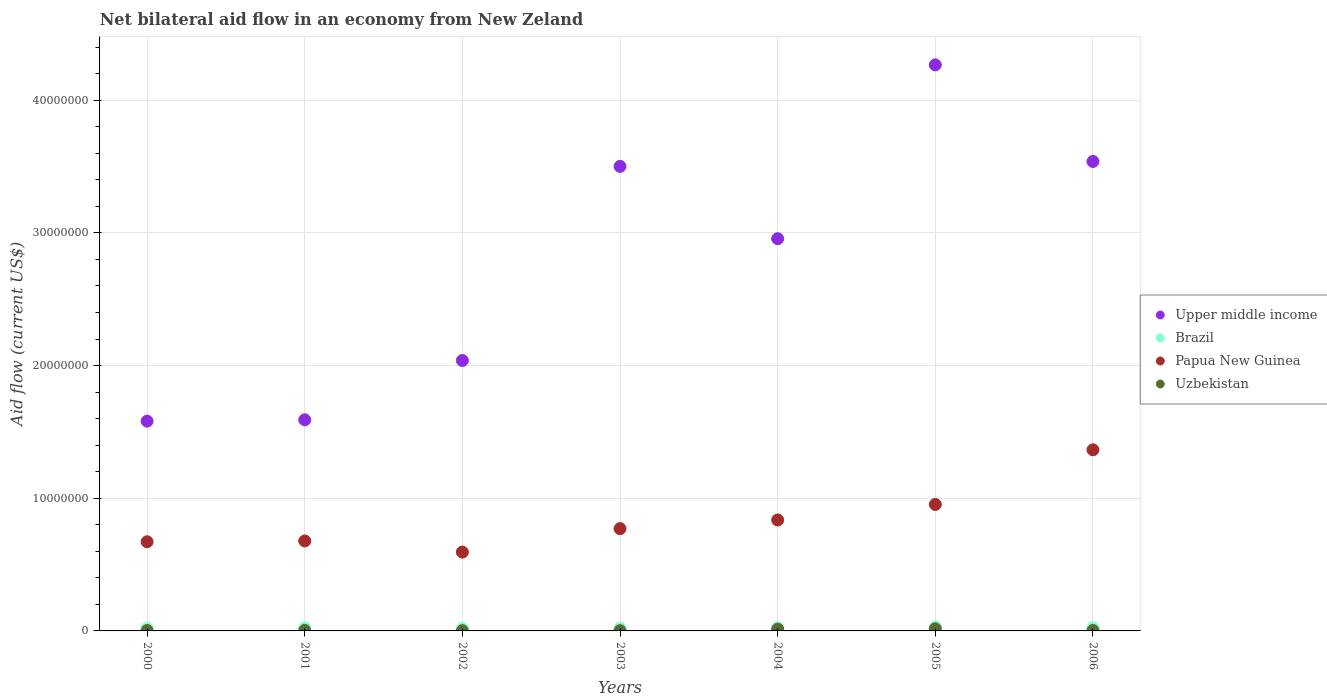What is the net bilateral aid flow in Papua New Guinea in 2001?
Give a very brief answer. 6.78e+06. Across all years, what is the minimum net bilateral aid flow in Uzbekistan?
Provide a short and direct response. 2.00e+04. In which year was the net bilateral aid flow in Papua New Guinea maximum?
Offer a very short reply. 2006. In which year was the net bilateral aid flow in Upper middle income minimum?
Offer a very short reply. 2000. What is the difference between the net bilateral aid flow in Uzbekistan in 2000 and that in 2006?
Your answer should be compact. 0. What is the average net bilateral aid flow in Upper middle income per year?
Provide a succinct answer. 2.78e+07. In the year 2006, what is the difference between the net bilateral aid flow in Papua New Guinea and net bilateral aid flow in Brazil?
Your answer should be compact. 1.34e+07. What is the ratio of the net bilateral aid flow in Brazil in 2003 to that in 2005?
Your answer should be compact. 0.69. Is the net bilateral aid flow in Brazil in 2005 less than that in 2006?
Make the answer very short. No. What is the difference between the highest and the lowest net bilateral aid flow in Papua New Guinea?
Offer a very short reply. 7.71e+06. Is the net bilateral aid flow in Upper middle income strictly greater than the net bilateral aid flow in Uzbekistan over the years?
Offer a very short reply. Yes. How many years are there in the graph?
Offer a very short reply. 7. Where does the legend appear in the graph?
Keep it short and to the point. Center right. How many legend labels are there?
Ensure brevity in your answer.  4. How are the legend labels stacked?
Provide a short and direct response. Vertical. What is the title of the graph?
Offer a terse response. Net bilateral aid flow in an economy from New Zeland. What is the label or title of the Y-axis?
Provide a short and direct response. Aid flow (current US$). What is the Aid flow (current US$) of Upper middle income in 2000?
Provide a succinct answer. 1.58e+07. What is the Aid flow (current US$) of Brazil in 2000?
Give a very brief answer. 2.10e+05. What is the Aid flow (current US$) in Papua New Guinea in 2000?
Keep it short and to the point. 6.72e+06. What is the Aid flow (current US$) in Uzbekistan in 2000?
Ensure brevity in your answer.  3.00e+04. What is the Aid flow (current US$) of Upper middle income in 2001?
Give a very brief answer. 1.59e+07. What is the Aid flow (current US$) in Papua New Guinea in 2001?
Give a very brief answer. 6.78e+06. What is the Aid flow (current US$) of Uzbekistan in 2001?
Provide a short and direct response. 4.00e+04. What is the Aid flow (current US$) of Upper middle income in 2002?
Offer a very short reply. 2.04e+07. What is the Aid flow (current US$) of Papua New Guinea in 2002?
Give a very brief answer. 5.94e+06. What is the Aid flow (current US$) in Uzbekistan in 2002?
Your answer should be compact. 2.00e+04. What is the Aid flow (current US$) in Upper middle income in 2003?
Offer a very short reply. 3.50e+07. What is the Aid flow (current US$) of Papua New Guinea in 2003?
Keep it short and to the point. 7.71e+06. What is the Aid flow (current US$) of Uzbekistan in 2003?
Offer a terse response. 2.00e+04. What is the Aid flow (current US$) in Upper middle income in 2004?
Your answer should be compact. 2.96e+07. What is the Aid flow (current US$) in Brazil in 2004?
Make the answer very short. 2.40e+05. What is the Aid flow (current US$) in Papua New Guinea in 2004?
Provide a succinct answer. 8.36e+06. What is the Aid flow (current US$) in Upper middle income in 2005?
Offer a very short reply. 4.27e+07. What is the Aid flow (current US$) in Brazil in 2005?
Offer a very short reply. 2.90e+05. What is the Aid flow (current US$) in Papua New Guinea in 2005?
Your answer should be very brief. 9.53e+06. What is the Aid flow (current US$) in Upper middle income in 2006?
Offer a terse response. 3.54e+07. What is the Aid flow (current US$) of Papua New Guinea in 2006?
Your response must be concise. 1.36e+07. Across all years, what is the maximum Aid flow (current US$) of Upper middle income?
Your answer should be very brief. 4.27e+07. Across all years, what is the maximum Aid flow (current US$) of Papua New Guinea?
Keep it short and to the point. 1.36e+07. Across all years, what is the minimum Aid flow (current US$) in Upper middle income?
Provide a succinct answer. 1.58e+07. Across all years, what is the minimum Aid flow (current US$) in Brazil?
Offer a terse response. 1.80e+05. Across all years, what is the minimum Aid flow (current US$) in Papua New Guinea?
Offer a terse response. 5.94e+06. Across all years, what is the minimum Aid flow (current US$) of Uzbekistan?
Offer a terse response. 2.00e+04. What is the total Aid flow (current US$) of Upper middle income in the graph?
Your response must be concise. 1.95e+08. What is the total Aid flow (current US$) of Brazil in the graph?
Your answer should be compact. 1.60e+06. What is the total Aid flow (current US$) of Papua New Guinea in the graph?
Ensure brevity in your answer.  5.87e+07. What is the total Aid flow (current US$) of Uzbekistan in the graph?
Offer a terse response. 4.30e+05. What is the difference between the Aid flow (current US$) in Brazil in 2000 and that in 2001?
Offer a very short reply. -3.00e+04. What is the difference between the Aid flow (current US$) of Papua New Guinea in 2000 and that in 2001?
Your response must be concise. -6.00e+04. What is the difference between the Aid flow (current US$) in Upper middle income in 2000 and that in 2002?
Keep it short and to the point. -4.57e+06. What is the difference between the Aid flow (current US$) of Papua New Guinea in 2000 and that in 2002?
Provide a short and direct response. 7.80e+05. What is the difference between the Aid flow (current US$) of Upper middle income in 2000 and that in 2003?
Offer a terse response. -1.92e+07. What is the difference between the Aid flow (current US$) in Brazil in 2000 and that in 2003?
Make the answer very short. 10000. What is the difference between the Aid flow (current US$) in Papua New Guinea in 2000 and that in 2003?
Ensure brevity in your answer.  -9.90e+05. What is the difference between the Aid flow (current US$) of Uzbekistan in 2000 and that in 2003?
Your response must be concise. 10000. What is the difference between the Aid flow (current US$) in Upper middle income in 2000 and that in 2004?
Provide a succinct answer. -1.38e+07. What is the difference between the Aid flow (current US$) of Papua New Guinea in 2000 and that in 2004?
Your response must be concise. -1.64e+06. What is the difference between the Aid flow (current US$) of Uzbekistan in 2000 and that in 2004?
Offer a terse response. -1.00e+05. What is the difference between the Aid flow (current US$) of Upper middle income in 2000 and that in 2005?
Offer a terse response. -2.68e+07. What is the difference between the Aid flow (current US$) in Brazil in 2000 and that in 2005?
Offer a terse response. -8.00e+04. What is the difference between the Aid flow (current US$) of Papua New Guinea in 2000 and that in 2005?
Your answer should be compact. -2.81e+06. What is the difference between the Aid flow (current US$) of Upper middle income in 2000 and that in 2006?
Provide a succinct answer. -1.96e+07. What is the difference between the Aid flow (current US$) of Brazil in 2000 and that in 2006?
Provide a succinct answer. -3.00e+04. What is the difference between the Aid flow (current US$) in Papua New Guinea in 2000 and that in 2006?
Ensure brevity in your answer.  -6.93e+06. What is the difference between the Aid flow (current US$) of Uzbekistan in 2000 and that in 2006?
Provide a short and direct response. 0. What is the difference between the Aid flow (current US$) in Upper middle income in 2001 and that in 2002?
Offer a terse response. -4.47e+06. What is the difference between the Aid flow (current US$) in Papua New Guinea in 2001 and that in 2002?
Your response must be concise. 8.40e+05. What is the difference between the Aid flow (current US$) in Upper middle income in 2001 and that in 2003?
Offer a very short reply. -1.91e+07. What is the difference between the Aid flow (current US$) of Papua New Guinea in 2001 and that in 2003?
Offer a terse response. -9.30e+05. What is the difference between the Aid flow (current US$) in Uzbekistan in 2001 and that in 2003?
Provide a short and direct response. 2.00e+04. What is the difference between the Aid flow (current US$) in Upper middle income in 2001 and that in 2004?
Make the answer very short. -1.36e+07. What is the difference between the Aid flow (current US$) of Brazil in 2001 and that in 2004?
Offer a terse response. 0. What is the difference between the Aid flow (current US$) in Papua New Guinea in 2001 and that in 2004?
Offer a terse response. -1.58e+06. What is the difference between the Aid flow (current US$) of Upper middle income in 2001 and that in 2005?
Your answer should be very brief. -2.68e+07. What is the difference between the Aid flow (current US$) of Papua New Guinea in 2001 and that in 2005?
Give a very brief answer. -2.75e+06. What is the difference between the Aid flow (current US$) in Uzbekistan in 2001 and that in 2005?
Provide a succinct answer. -1.20e+05. What is the difference between the Aid flow (current US$) in Upper middle income in 2001 and that in 2006?
Keep it short and to the point. -1.95e+07. What is the difference between the Aid flow (current US$) of Papua New Guinea in 2001 and that in 2006?
Keep it short and to the point. -6.87e+06. What is the difference between the Aid flow (current US$) in Uzbekistan in 2001 and that in 2006?
Your response must be concise. 10000. What is the difference between the Aid flow (current US$) of Upper middle income in 2002 and that in 2003?
Give a very brief answer. -1.46e+07. What is the difference between the Aid flow (current US$) of Papua New Guinea in 2002 and that in 2003?
Provide a succinct answer. -1.77e+06. What is the difference between the Aid flow (current US$) of Uzbekistan in 2002 and that in 2003?
Your answer should be very brief. 0. What is the difference between the Aid flow (current US$) of Upper middle income in 2002 and that in 2004?
Your answer should be compact. -9.18e+06. What is the difference between the Aid flow (current US$) of Brazil in 2002 and that in 2004?
Make the answer very short. -6.00e+04. What is the difference between the Aid flow (current US$) in Papua New Guinea in 2002 and that in 2004?
Your answer should be compact. -2.42e+06. What is the difference between the Aid flow (current US$) in Uzbekistan in 2002 and that in 2004?
Your response must be concise. -1.10e+05. What is the difference between the Aid flow (current US$) in Upper middle income in 2002 and that in 2005?
Your response must be concise. -2.23e+07. What is the difference between the Aid flow (current US$) of Brazil in 2002 and that in 2005?
Your answer should be compact. -1.10e+05. What is the difference between the Aid flow (current US$) of Papua New Guinea in 2002 and that in 2005?
Provide a succinct answer. -3.59e+06. What is the difference between the Aid flow (current US$) of Uzbekistan in 2002 and that in 2005?
Your answer should be compact. -1.40e+05. What is the difference between the Aid flow (current US$) of Upper middle income in 2002 and that in 2006?
Your answer should be compact. -1.50e+07. What is the difference between the Aid flow (current US$) of Papua New Guinea in 2002 and that in 2006?
Keep it short and to the point. -7.71e+06. What is the difference between the Aid flow (current US$) of Uzbekistan in 2002 and that in 2006?
Your answer should be compact. -10000. What is the difference between the Aid flow (current US$) of Upper middle income in 2003 and that in 2004?
Ensure brevity in your answer.  5.45e+06. What is the difference between the Aid flow (current US$) of Papua New Guinea in 2003 and that in 2004?
Your answer should be compact. -6.50e+05. What is the difference between the Aid flow (current US$) in Uzbekistan in 2003 and that in 2004?
Provide a short and direct response. -1.10e+05. What is the difference between the Aid flow (current US$) in Upper middle income in 2003 and that in 2005?
Make the answer very short. -7.65e+06. What is the difference between the Aid flow (current US$) of Brazil in 2003 and that in 2005?
Your answer should be compact. -9.00e+04. What is the difference between the Aid flow (current US$) in Papua New Guinea in 2003 and that in 2005?
Provide a succinct answer. -1.82e+06. What is the difference between the Aid flow (current US$) in Upper middle income in 2003 and that in 2006?
Provide a short and direct response. -3.70e+05. What is the difference between the Aid flow (current US$) of Papua New Guinea in 2003 and that in 2006?
Offer a very short reply. -5.94e+06. What is the difference between the Aid flow (current US$) of Upper middle income in 2004 and that in 2005?
Ensure brevity in your answer.  -1.31e+07. What is the difference between the Aid flow (current US$) of Brazil in 2004 and that in 2005?
Provide a short and direct response. -5.00e+04. What is the difference between the Aid flow (current US$) of Papua New Guinea in 2004 and that in 2005?
Offer a very short reply. -1.17e+06. What is the difference between the Aid flow (current US$) of Uzbekistan in 2004 and that in 2005?
Offer a very short reply. -3.00e+04. What is the difference between the Aid flow (current US$) in Upper middle income in 2004 and that in 2006?
Provide a short and direct response. -5.82e+06. What is the difference between the Aid flow (current US$) of Papua New Guinea in 2004 and that in 2006?
Your answer should be compact. -5.29e+06. What is the difference between the Aid flow (current US$) of Upper middle income in 2005 and that in 2006?
Your answer should be compact. 7.28e+06. What is the difference between the Aid flow (current US$) in Papua New Guinea in 2005 and that in 2006?
Your answer should be very brief. -4.12e+06. What is the difference between the Aid flow (current US$) in Uzbekistan in 2005 and that in 2006?
Make the answer very short. 1.30e+05. What is the difference between the Aid flow (current US$) of Upper middle income in 2000 and the Aid flow (current US$) of Brazil in 2001?
Your response must be concise. 1.56e+07. What is the difference between the Aid flow (current US$) of Upper middle income in 2000 and the Aid flow (current US$) of Papua New Guinea in 2001?
Make the answer very short. 9.03e+06. What is the difference between the Aid flow (current US$) in Upper middle income in 2000 and the Aid flow (current US$) in Uzbekistan in 2001?
Keep it short and to the point. 1.58e+07. What is the difference between the Aid flow (current US$) of Brazil in 2000 and the Aid flow (current US$) of Papua New Guinea in 2001?
Ensure brevity in your answer.  -6.57e+06. What is the difference between the Aid flow (current US$) in Brazil in 2000 and the Aid flow (current US$) in Uzbekistan in 2001?
Your response must be concise. 1.70e+05. What is the difference between the Aid flow (current US$) in Papua New Guinea in 2000 and the Aid flow (current US$) in Uzbekistan in 2001?
Your answer should be compact. 6.68e+06. What is the difference between the Aid flow (current US$) of Upper middle income in 2000 and the Aid flow (current US$) of Brazil in 2002?
Keep it short and to the point. 1.56e+07. What is the difference between the Aid flow (current US$) in Upper middle income in 2000 and the Aid flow (current US$) in Papua New Guinea in 2002?
Provide a succinct answer. 9.87e+06. What is the difference between the Aid flow (current US$) of Upper middle income in 2000 and the Aid flow (current US$) of Uzbekistan in 2002?
Make the answer very short. 1.58e+07. What is the difference between the Aid flow (current US$) of Brazil in 2000 and the Aid flow (current US$) of Papua New Guinea in 2002?
Ensure brevity in your answer.  -5.73e+06. What is the difference between the Aid flow (current US$) of Brazil in 2000 and the Aid flow (current US$) of Uzbekistan in 2002?
Your answer should be very brief. 1.90e+05. What is the difference between the Aid flow (current US$) in Papua New Guinea in 2000 and the Aid flow (current US$) in Uzbekistan in 2002?
Keep it short and to the point. 6.70e+06. What is the difference between the Aid flow (current US$) in Upper middle income in 2000 and the Aid flow (current US$) in Brazil in 2003?
Keep it short and to the point. 1.56e+07. What is the difference between the Aid flow (current US$) in Upper middle income in 2000 and the Aid flow (current US$) in Papua New Guinea in 2003?
Keep it short and to the point. 8.10e+06. What is the difference between the Aid flow (current US$) of Upper middle income in 2000 and the Aid flow (current US$) of Uzbekistan in 2003?
Keep it short and to the point. 1.58e+07. What is the difference between the Aid flow (current US$) in Brazil in 2000 and the Aid flow (current US$) in Papua New Guinea in 2003?
Make the answer very short. -7.50e+06. What is the difference between the Aid flow (current US$) in Papua New Guinea in 2000 and the Aid flow (current US$) in Uzbekistan in 2003?
Offer a terse response. 6.70e+06. What is the difference between the Aid flow (current US$) in Upper middle income in 2000 and the Aid flow (current US$) in Brazil in 2004?
Provide a succinct answer. 1.56e+07. What is the difference between the Aid flow (current US$) of Upper middle income in 2000 and the Aid flow (current US$) of Papua New Guinea in 2004?
Your answer should be compact. 7.45e+06. What is the difference between the Aid flow (current US$) in Upper middle income in 2000 and the Aid flow (current US$) in Uzbekistan in 2004?
Offer a very short reply. 1.57e+07. What is the difference between the Aid flow (current US$) in Brazil in 2000 and the Aid flow (current US$) in Papua New Guinea in 2004?
Give a very brief answer. -8.15e+06. What is the difference between the Aid flow (current US$) in Papua New Guinea in 2000 and the Aid flow (current US$) in Uzbekistan in 2004?
Offer a very short reply. 6.59e+06. What is the difference between the Aid flow (current US$) of Upper middle income in 2000 and the Aid flow (current US$) of Brazil in 2005?
Offer a terse response. 1.55e+07. What is the difference between the Aid flow (current US$) in Upper middle income in 2000 and the Aid flow (current US$) in Papua New Guinea in 2005?
Offer a terse response. 6.28e+06. What is the difference between the Aid flow (current US$) of Upper middle income in 2000 and the Aid flow (current US$) of Uzbekistan in 2005?
Give a very brief answer. 1.56e+07. What is the difference between the Aid flow (current US$) of Brazil in 2000 and the Aid flow (current US$) of Papua New Guinea in 2005?
Offer a very short reply. -9.32e+06. What is the difference between the Aid flow (current US$) in Papua New Guinea in 2000 and the Aid flow (current US$) in Uzbekistan in 2005?
Make the answer very short. 6.56e+06. What is the difference between the Aid flow (current US$) of Upper middle income in 2000 and the Aid flow (current US$) of Brazil in 2006?
Your answer should be compact. 1.56e+07. What is the difference between the Aid flow (current US$) in Upper middle income in 2000 and the Aid flow (current US$) in Papua New Guinea in 2006?
Ensure brevity in your answer.  2.16e+06. What is the difference between the Aid flow (current US$) in Upper middle income in 2000 and the Aid flow (current US$) in Uzbekistan in 2006?
Offer a terse response. 1.58e+07. What is the difference between the Aid flow (current US$) in Brazil in 2000 and the Aid flow (current US$) in Papua New Guinea in 2006?
Ensure brevity in your answer.  -1.34e+07. What is the difference between the Aid flow (current US$) in Papua New Guinea in 2000 and the Aid flow (current US$) in Uzbekistan in 2006?
Make the answer very short. 6.69e+06. What is the difference between the Aid flow (current US$) of Upper middle income in 2001 and the Aid flow (current US$) of Brazil in 2002?
Give a very brief answer. 1.57e+07. What is the difference between the Aid flow (current US$) in Upper middle income in 2001 and the Aid flow (current US$) in Papua New Guinea in 2002?
Keep it short and to the point. 9.97e+06. What is the difference between the Aid flow (current US$) in Upper middle income in 2001 and the Aid flow (current US$) in Uzbekistan in 2002?
Provide a short and direct response. 1.59e+07. What is the difference between the Aid flow (current US$) in Brazil in 2001 and the Aid flow (current US$) in Papua New Guinea in 2002?
Ensure brevity in your answer.  -5.70e+06. What is the difference between the Aid flow (current US$) of Papua New Guinea in 2001 and the Aid flow (current US$) of Uzbekistan in 2002?
Ensure brevity in your answer.  6.76e+06. What is the difference between the Aid flow (current US$) of Upper middle income in 2001 and the Aid flow (current US$) of Brazil in 2003?
Make the answer very short. 1.57e+07. What is the difference between the Aid flow (current US$) in Upper middle income in 2001 and the Aid flow (current US$) in Papua New Guinea in 2003?
Your answer should be very brief. 8.20e+06. What is the difference between the Aid flow (current US$) in Upper middle income in 2001 and the Aid flow (current US$) in Uzbekistan in 2003?
Your response must be concise. 1.59e+07. What is the difference between the Aid flow (current US$) of Brazil in 2001 and the Aid flow (current US$) of Papua New Guinea in 2003?
Your response must be concise. -7.47e+06. What is the difference between the Aid flow (current US$) in Brazil in 2001 and the Aid flow (current US$) in Uzbekistan in 2003?
Offer a terse response. 2.20e+05. What is the difference between the Aid flow (current US$) in Papua New Guinea in 2001 and the Aid flow (current US$) in Uzbekistan in 2003?
Your answer should be very brief. 6.76e+06. What is the difference between the Aid flow (current US$) in Upper middle income in 2001 and the Aid flow (current US$) in Brazil in 2004?
Your answer should be very brief. 1.57e+07. What is the difference between the Aid flow (current US$) of Upper middle income in 2001 and the Aid flow (current US$) of Papua New Guinea in 2004?
Your answer should be compact. 7.55e+06. What is the difference between the Aid flow (current US$) of Upper middle income in 2001 and the Aid flow (current US$) of Uzbekistan in 2004?
Keep it short and to the point. 1.58e+07. What is the difference between the Aid flow (current US$) of Brazil in 2001 and the Aid flow (current US$) of Papua New Guinea in 2004?
Your answer should be compact. -8.12e+06. What is the difference between the Aid flow (current US$) of Papua New Guinea in 2001 and the Aid flow (current US$) of Uzbekistan in 2004?
Give a very brief answer. 6.65e+06. What is the difference between the Aid flow (current US$) of Upper middle income in 2001 and the Aid flow (current US$) of Brazil in 2005?
Your response must be concise. 1.56e+07. What is the difference between the Aid flow (current US$) in Upper middle income in 2001 and the Aid flow (current US$) in Papua New Guinea in 2005?
Offer a terse response. 6.38e+06. What is the difference between the Aid flow (current US$) in Upper middle income in 2001 and the Aid flow (current US$) in Uzbekistan in 2005?
Give a very brief answer. 1.58e+07. What is the difference between the Aid flow (current US$) of Brazil in 2001 and the Aid flow (current US$) of Papua New Guinea in 2005?
Your answer should be very brief. -9.29e+06. What is the difference between the Aid flow (current US$) of Papua New Guinea in 2001 and the Aid flow (current US$) of Uzbekistan in 2005?
Provide a short and direct response. 6.62e+06. What is the difference between the Aid flow (current US$) in Upper middle income in 2001 and the Aid flow (current US$) in Brazil in 2006?
Offer a terse response. 1.57e+07. What is the difference between the Aid flow (current US$) of Upper middle income in 2001 and the Aid flow (current US$) of Papua New Guinea in 2006?
Keep it short and to the point. 2.26e+06. What is the difference between the Aid flow (current US$) of Upper middle income in 2001 and the Aid flow (current US$) of Uzbekistan in 2006?
Give a very brief answer. 1.59e+07. What is the difference between the Aid flow (current US$) of Brazil in 2001 and the Aid flow (current US$) of Papua New Guinea in 2006?
Keep it short and to the point. -1.34e+07. What is the difference between the Aid flow (current US$) in Brazil in 2001 and the Aid flow (current US$) in Uzbekistan in 2006?
Provide a short and direct response. 2.10e+05. What is the difference between the Aid flow (current US$) of Papua New Guinea in 2001 and the Aid flow (current US$) of Uzbekistan in 2006?
Your answer should be compact. 6.75e+06. What is the difference between the Aid flow (current US$) of Upper middle income in 2002 and the Aid flow (current US$) of Brazil in 2003?
Keep it short and to the point. 2.02e+07. What is the difference between the Aid flow (current US$) of Upper middle income in 2002 and the Aid flow (current US$) of Papua New Guinea in 2003?
Ensure brevity in your answer.  1.27e+07. What is the difference between the Aid flow (current US$) in Upper middle income in 2002 and the Aid flow (current US$) in Uzbekistan in 2003?
Ensure brevity in your answer.  2.04e+07. What is the difference between the Aid flow (current US$) in Brazil in 2002 and the Aid flow (current US$) in Papua New Guinea in 2003?
Your response must be concise. -7.53e+06. What is the difference between the Aid flow (current US$) of Brazil in 2002 and the Aid flow (current US$) of Uzbekistan in 2003?
Offer a terse response. 1.60e+05. What is the difference between the Aid flow (current US$) of Papua New Guinea in 2002 and the Aid flow (current US$) of Uzbekistan in 2003?
Give a very brief answer. 5.92e+06. What is the difference between the Aid flow (current US$) in Upper middle income in 2002 and the Aid flow (current US$) in Brazil in 2004?
Keep it short and to the point. 2.01e+07. What is the difference between the Aid flow (current US$) of Upper middle income in 2002 and the Aid flow (current US$) of Papua New Guinea in 2004?
Offer a very short reply. 1.20e+07. What is the difference between the Aid flow (current US$) in Upper middle income in 2002 and the Aid flow (current US$) in Uzbekistan in 2004?
Keep it short and to the point. 2.02e+07. What is the difference between the Aid flow (current US$) in Brazil in 2002 and the Aid flow (current US$) in Papua New Guinea in 2004?
Your response must be concise. -8.18e+06. What is the difference between the Aid flow (current US$) in Papua New Guinea in 2002 and the Aid flow (current US$) in Uzbekistan in 2004?
Make the answer very short. 5.81e+06. What is the difference between the Aid flow (current US$) of Upper middle income in 2002 and the Aid flow (current US$) of Brazil in 2005?
Provide a succinct answer. 2.01e+07. What is the difference between the Aid flow (current US$) of Upper middle income in 2002 and the Aid flow (current US$) of Papua New Guinea in 2005?
Your answer should be very brief. 1.08e+07. What is the difference between the Aid flow (current US$) in Upper middle income in 2002 and the Aid flow (current US$) in Uzbekistan in 2005?
Provide a short and direct response. 2.02e+07. What is the difference between the Aid flow (current US$) in Brazil in 2002 and the Aid flow (current US$) in Papua New Guinea in 2005?
Give a very brief answer. -9.35e+06. What is the difference between the Aid flow (current US$) in Brazil in 2002 and the Aid flow (current US$) in Uzbekistan in 2005?
Offer a very short reply. 2.00e+04. What is the difference between the Aid flow (current US$) in Papua New Guinea in 2002 and the Aid flow (current US$) in Uzbekistan in 2005?
Make the answer very short. 5.78e+06. What is the difference between the Aid flow (current US$) in Upper middle income in 2002 and the Aid flow (current US$) in Brazil in 2006?
Ensure brevity in your answer.  2.01e+07. What is the difference between the Aid flow (current US$) in Upper middle income in 2002 and the Aid flow (current US$) in Papua New Guinea in 2006?
Your response must be concise. 6.73e+06. What is the difference between the Aid flow (current US$) of Upper middle income in 2002 and the Aid flow (current US$) of Uzbekistan in 2006?
Provide a succinct answer. 2.04e+07. What is the difference between the Aid flow (current US$) in Brazil in 2002 and the Aid flow (current US$) in Papua New Guinea in 2006?
Ensure brevity in your answer.  -1.35e+07. What is the difference between the Aid flow (current US$) in Brazil in 2002 and the Aid flow (current US$) in Uzbekistan in 2006?
Your answer should be very brief. 1.50e+05. What is the difference between the Aid flow (current US$) in Papua New Guinea in 2002 and the Aid flow (current US$) in Uzbekistan in 2006?
Offer a terse response. 5.91e+06. What is the difference between the Aid flow (current US$) in Upper middle income in 2003 and the Aid flow (current US$) in Brazil in 2004?
Give a very brief answer. 3.48e+07. What is the difference between the Aid flow (current US$) in Upper middle income in 2003 and the Aid flow (current US$) in Papua New Guinea in 2004?
Make the answer very short. 2.66e+07. What is the difference between the Aid flow (current US$) of Upper middle income in 2003 and the Aid flow (current US$) of Uzbekistan in 2004?
Give a very brief answer. 3.49e+07. What is the difference between the Aid flow (current US$) of Brazil in 2003 and the Aid flow (current US$) of Papua New Guinea in 2004?
Offer a terse response. -8.16e+06. What is the difference between the Aid flow (current US$) of Papua New Guinea in 2003 and the Aid flow (current US$) of Uzbekistan in 2004?
Keep it short and to the point. 7.58e+06. What is the difference between the Aid flow (current US$) of Upper middle income in 2003 and the Aid flow (current US$) of Brazil in 2005?
Give a very brief answer. 3.47e+07. What is the difference between the Aid flow (current US$) in Upper middle income in 2003 and the Aid flow (current US$) in Papua New Guinea in 2005?
Give a very brief answer. 2.55e+07. What is the difference between the Aid flow (current US$) of Upper middle income in 2003 and the Aid flow (current US$) of Uzbekistan in 2005?
Give a very brief answer. 3.48e+07. What is the difference between the Aid flow (current US$) of Brazil in 2003 and the Aid flow (current US$) of Papua New Guinea in 2005?
Provide a succinct answer. -9.33e+06. What is the difference between the Aid flow (current US$) of Brazil in 2003 and the Aid flow (current US$) of Uzbekistan in 2005?
Give a very brief answer. 4.00e+04. What is the difference between the Aid flow (current US$) of Papua New Guinea in 2003 and the Aid flow (current US$) of Uzbekistan in 2005?
Provide a succinct answer. 7.55e+06. What is the difference between the Aid flow (current US$) of Upper middle income in 2003 and the Aid flow (current US$) of Brazil in 2006?
Your answer should be very brief. 3.48e+07. What is the difference between the Aid flow (current US$) in Upper middle income in 2003 and the Aid flow (current US$) in Papua New Guinea in 2006?
Your response must be concise. 2.14e+07. What is the difference between the Aid flow (current US$) in Upper middle income in 2003 and the Aid flow (current US$) in Uzbekistan in 2006?
Keep it short and to the point. 3.50e+07. What is the difference between the Aid flow (current US$) of Brazil in 2003 and the Aid flow (current US$) of Papua New Guinea in 2006?
Keep it short and to the point. -1.34e+07. What is the difference between the Aid flow (current US$) in Brazil in 2003 and the Aid flow (current US$) in Uzbekistan in 2006?
Make the answer very short. 1.70e+05. What is the difference between the Aid flow (current US$) in Papua New Guinea in 2003 and the Aid flow (current US$) in Uzbekistan in 2006?
Provide a short and direct response. 7.68e+06. What is the difference between the Aid flow (current US$) in Upper middle income in 2004 and the Aid flow (current US$) in Brazil in 2005?
Ensure brevity in your answer.  2.93e+07. What is the difference between the Aid flow (current US$) of Upper middle income in 2004 and the Aid flow (current US$) of Papua New Guinea in 2005?
Your answer should be compact. 2.00e+07. What is the difference between the Aid flow (current US$) in Upper middle income in 2004 and the Aid flow (current US$) in Uzbekistan in 2005?
Provide a succinct answer. 2.94e+07. What is the difference between the Aid flow (current US$) in Brazil in 2004 and the Aid flow (current US$) in Papua New Guinea in 2005?
Give a very brief answer. -9.29e+06. What is the difference between the Aid flow (current US$) of Papua New Guinea in 2004 and the Aid flow (current US$) of Uzbekistan in 2005?
Your answer should be very brief. 8.20e+06. What is the difference between the Aid flow (current US$) of Upper middle income in 2004 and the Aid flow (current US$) of Brazil in 2006?
Offer a terse response. 2.93e+07. What is the difference between the Aid flow (current US$) in Upper middle income in 2004 and the Aid flow (current US$) in Papua New Guinea in 2006?
Offer a terse response. 1.59e+07. What is the difference between the Aid flow (current US$) of Upper middle income in 2004 and the Aid flow (current US$) of Uzbekistan in 2006?
Offer a very short reply. 2.95e+07. What is the difference between the Aid flow (current US$) in Brazil in 2004 and the Aid flow (current US$) in Papua New Guinea in 2006?
Give a very brief answer. -1.34e+07. What is the difference between the Aid flow (current US$) in Papua New Guinea in 2004 and the Aid flow (current US$) in Uzbekistan in 2006?
Give a very brief answer. 8.33e+06. What is the difference between the Aid flow (current US$) of Upper middle income in 2005 and the Aid flow (current US$) of Brazil in 2006?
Offer a very short reply. 4.24e+07. What is the difference between the Aid flow (current US$) of Upper middle income in 2005 and the Aid flow (current US$) of Papua New Guinea in 2006?
Ensure brevity in your answer.  2.90e+07. What is the difference between the Aid flow (current US$) in Upper middle income in 2005 and the Aid flow (current US$) in Uzbekistan in 2006?
Provide a short and direct response. 4.26e+07. What is the difference between the Aid flow (current US$) of Brazil in 2005 and the Aid flow (current US$) of Papua New Guinea in 2006?
Give a very brief answer. -1.34e+07. What is the difference between the Aid flow (current US$) in Papua New Guinea in 2005 and the Aid flow (current US$) in Uzbekistan in 2006?
Keep it short and to the point. 9.50e+06. What is the average Aid flow (current US$) of Upper middle income per year?
Make the answer very short. 2.78e+07. What is the average Aid flow (current US$) in Brazil per year?
Your response must be concise. 2.29e+05. What is the average Aid flow (current US$) of Papua New Guinea per year?
Provide a short and direct response. 8.38e+06. What is the average Aid flow (current US$) in Uzbekistan per year?
Offer a terse response. 6.14e+04. In the year 2000, what is the difference between the Aid flow (current US$) in Upper middle income and Aid flow (current US$) in Brazil?
Your response must be concise. 1.56e+07. In the year 2000, what is the difference between the Aid flow (current US$) in Upper middle income and Aid flow (current US$) in Papua New Guinea?
Provide a short and direct response. 9.09e+06. In the year 2000, what is the difference between the Aid flow (current US$) in Upper middle income and Aid flow (current US$) in Uzbekistan?
Your answer should be very brief. 1.58e+07. In the year 2000, what is the difference between the Aid flow (current US$) in Brazil and Aid flow (current US$) in Papua New Guinea?
Your answer should be very brief. -6.51e+06. In the year 2000, what is the difference between the Aid flow (current US$) in Brazil and Aid flow (current US$) in Uzbekistan?
Your answer should be compact. 1.80e+05. In the year 2000, what is the difference between the Aid flow (current US$) of Papua New Guinea and Aid flow (current US$) of Uzbekistan?
Keep it short and to the point. 6.69e+06. In the year 2001, what is the difference between the Aid flow (current US$) of Upper middle income and Aid flow (current US$) of Brazil?
Ensure brevity in your answer.  1.57e+07. In the year 2001, what is the difference between the Aid flow (current US$) in Upper middle income and Aid flow (current US$) in Papua New Guinea?
Provide a short and direct response. 9.13e+06. In the year 2001, what is the difference between the Aid flow (current US$) of Upper middle income and Aid flow (current US$) of Uzbekistan?
Provide a succinct answer. 1.59e+07. In the year 2001, what is the difference between the Aid flow (current US$) in Brazil and Aid flow (current US$) in Papua New Guinea?
Your answer should be compact. -6.54e+06. In the year 2001, what is the difference between the Aid flow (current US$) in Brazil and Aid flow (current US$) in Uzbekistan?
Your answer should be very brief. 2.00e+05. In the year 2001, what is the difference between the Aid flow (current US$) of Papua New Guinea and Aid flow (current US$) of Uzbekistan?
Make the answer very short. 6.74e+06. In the year 2002, what is the difference between the Aid flow (current US$) of Upper middle income and Aid flow (current US$) of Brazil?
Offer a very short reply. 2.02e+07. In the year 2002, what is the difference between the Aid flow (current US$) of Upper middle income and Aid flow (current US$) of Papua New Guinea?
Your answer should be compact. 1.44e+07. In the year 2002, what is the difference between the Aid flow (current US$) of Upper middle income and Aid flow (current US$) of Uzbekistan?
Offer a terse response. 2.04e+07. In the year 2002, what is the difference between the Aid flow (current US$) in Brazil and Aid flow (current US$) in Papua New Guinea?
Your answer should be compact. -5.76e+06. In the year 2002, what is the difference between the Aid flow (current US$) in Papua New Guinea and Aid flow (current US$) in Uzbekistan?
Provide a succinct answer. 5.92e+06. In the year 2003, what is the difference between the Aid flow (current US$) in Upper middle income and Aid flow (current US$) in Brazil?
Keep it short and to the point. 3.48e+07. In the year 2003, what is the difference between the Aid flow (current US$) of Upper middle income and Aid flow (current US$) of Papua New Guinea?
Your answer should be compact. 2.73e+07. In the year 2003, what is the difference between the Aid flow (current US$) of Upper middle income and Aid flow (current US$) of Uzbekistan?
Give a very brief answer. 3.50e+07. In the year 2003, what is the difference between the Aid flow (current US$) of Brazil and Aid flow (current US$) of Papua New Guinea?
Provide a succinct answer. -7.51e+06. In the year 2003, what is the difference between the Aid flow (current US$) of Brazil and Aid flow (current US$) of Uzbekistan?
Provide a short and direct response. 1.80e+05. In the year 2003, what is the difference between the Aid flow (current US$) of Papua New Guinea and Aid flow (current US$) of Uzbekistan?
Your answer should be very brief. 7.69e+06. In the year 2004, what is the difference between the Aid flow (current US$) of Upper middle income and Aid flow (current US$) of Brazil?
Offer a terse response. 2.93e+07. In the year 2004, what is the difference between the Aid flow (current US$) of Upper middle income and Aid flow (current US$) of Papua New Guinea?
Your answer should be compact. 2.12e+07. In the year 2004, what is the difference between the Aid flow (current US$) in Upper middle income and Aid flow (current US$) in Uzbekistan?
Make the answer very short. 2.94e+07. In the year 2004, what is the difference between the Aid flow (current US$) of Brazil and Aid flow (current US$) of Papua New Guinea?
Your answer should be very brief. -8.12e+06. In the year 2004, what is the difference between the Aid flow (current US$) in Brazil and Aid flow (current US$) in Uzbekistan?
Keep it short and to the point. 1.10e+05. In the year 2004, what is the difference between the Aid flow (current US$) in Papua New Guinea and Aid flow (current US$) in Uzbekistan?
Ensure brevity in your answer.  8.23e+06. In the year 2005, what is the difference between the Aid flow (current US$) of Upper middle income and Aid flow (current US$) of Brazil?
Provide a succinct answer. 4.24e+07. In the year 2005, what is the difference between the Aid flow (current US$) in Upper middle income and Aid flow (current US$) in Papua New Guinea?
Your answer should be very brief. 3.31e+07. In the year 2005, what is the difference between the Aid flow (current US$) in Upper middle income and Aid flow (current US$) in Uzbekistan?
Your response must be concise. 4.25e+07. In the year 2005, what is the difference between the Aid flow (current US$) of Brazil and Aid flow (current US$) of Papua New Guinea?
Your answer should be very brief. -9.24e+06. In the year 2005, what is the difference between the Aid flow (current US$) of Papua New Guinea and Aid flow (current US$) of Uzbekistan?
Provide a short and direct response. 9.37e+06. In the year 2006, what is the difference between the Aid flow (current US$) of Upper middle income and Aid flow (current US$) of Brazil?
Your answer should be compact. 3.51e+07. In the year 2006, what is the difference between the Aid flow (current US$) of Upper middle income and Aid flow (current US$) of Papua New Guinea?
Ensure brevity in your answer.  2.17e+07. In the year 2006, what is the difference between the Aid flow (current US$) in Upper middle income and Aid flow (current US$) in Uzbekistan?
Keep it short and to the point. 3.54e+07. In the year 2006, what is the difference between the Aid flow (current US$) in Brazil and Aid flow (current US$) in Papua New Guinea?
Ensure brevity in your answer.  -1.34e+07. In the year 2006, what is the difference between the Aid flow (current US$) in Papua New Guinea and Aid flow (current US$) in Uzbekistan?
Offer a terse response. 1.36e+07. What is the ratio of the Aid flow (current US$) in Upper middle income in 2000 to that in 2001?
Provide a short and direct response. 0.99. What is the ratio of the Aid flow (current US$) in Uzbekistan in 2000 to that in 2001?
Make the answer very short. 0.75. What is the ratio of the Aid flow (current US$) in Upper middle income in 2000 to that in 2002?
Your answer should be compact. 0.78. What is the ratio of the Aid flow (current US$) in Papua New Guinea in 2000 to that in 2002?
Make the answer very short. 1.13. What is the ratio of the Aid flow (current US$) of Upper middle income in 2000 to that in 2003?
Offer a very short reply. 0.45. What is the ratio of the Aid flow (current US$) in Papua New Guinea in 2000 to that in 2003?
Offer a terse response. 0.87. What is the ratio of the Aid flow (current US$) of Uzbekistan in 2000 to that in 2003?
Give a very brief answer. 1.5. What is the ratio of the Aid flow (current US$) in Upper middle income in 2000 to that in 2004?
Your answer should be very brief. 0.53. What is the ratio of the Aid flow (current US$) in Papua New Guinea in 2000 to that in 2004?
Keep it short and to the point. 0.8. What is the ratio of the Aid flow (current US$) in Uzbekistan in 2000 to that in 2004?
Keep it short and to the point. 0.23. What is the ratio of the Aid flow (current US$) of Upper middle income in 2000 to that in 2005?
Your answer should be compact. 0.37. What is the ratio of the Aid flow (current US$) of Brazil in 2000 to that in 2005?
Your answer should be very brief. 0.72. What is the ratio of the Aid flow (current US$) in Papua New Guinea in 2000 to that in 2005?
Your answer should be very brief. 0.71. What is the ratio of the Aid flow (current US$) of Uzbekistan in 2000 to that in 2005?
Ensure brevity in your answer.  0.19. What is the ratio of the Aid flow (current US$) of Upper middle income in 2000 to that in 2006?
Keep it short and to the point. 0.45. What is the ratio of the Aid flow (current US$) in Papua New Guinea in 2000 to that in 2006?
Provide a succinct answer. 0.49. What is the ratio of the Aid flow (current US$) of Uzbekistan in 2000 to that in 2006?
Offer a terse response. 1. What is the ratio of the Aid flow (current US$) of Upper middle income in 2001 to that in 2002?
Your response must be concise. 0.78. What is the ratio of the Aid flow (current US$) in Papua New Guinea in 2001 to that in 2002?
Offer a very short reply. 1.14. What is the ratio of the Aid flow (current US$) of Upper middle income in 2001 to that in 2003?
Offer a very short reply. 0.45. What is the ratio of the Aid flow (current US$) of Papua New Guinea in 2001 to that in 2003?
Offer a terse response. 0.88. What is the ratio of the Aid flow (current US$) of Uzbekistan in 2001 to that in 2003?
Offer a very short reply. 2. What is the ratio of the Aid flow (current US$) in Upper middle income in 2001 to that in 2004?
Make the answer very short. 0.54. What is the ratio of the Aid flow (current US$) in Brazil in 2001 to that in 2004?
Ensure brevity in your answer.  1. What is the ratio of the Aid flow (current US$) in Papua New Guinea in 2001 to that in 2004?
Your answer should be compact. 0.81. What is the ratio of the Aid flow (current US$) of Uzbekistan in 2001 to that in 2004?
Keep it short and to the point. 0.31. What is the ratio of the Aid flow (current US$) of Upper middle income in 2001 to that in 2005?
Keep it short and to the point. 0.37. What is the ratio of the Aid flow (current US$) of Brazil in 2001 to that in 2005?
Make the answer very short. 0.83. What is the ratio of the Aid flow (current US$) of Papua New Guinea in 2001 to that in 2005?
Your answer should be very brief. 0.71. What is the ratio of the Aid flow (current US$) in Uzbekistan in 2001 to that in 2005?
Your answer should be very brief. 0.25. What is the ratio of the Aid flow (current US$) of Upper middle income in 2001 to that in 2006?
Provide a succinct answer. 0.45. What is the ratio of the Aid flow (current US$) of Brazil in 2001 to that in 2006?
Keep it short and to the point. 1. What is the ratio of the Aid flow (current US$) in Papua New Guinea in 2001 to that in 2006?
Give a very brief answer. 0.5. What is the ratio of the Aid flow (current US$) of Uzbekistan in 2001 to that in 2006?
Keep it short and to the point. 1.33. What is the ratio of the Aid flow (current US$) of Upper middle income in 2002 to that in 2003?
Provide a succinct answer. 0.58. What is the ratio of the Aid flow (current US$) of Papua New Guinea in 2002 to that in 2003?
Ensure brevity in your answer.  0.77. What is the ratio of the Aid flow (current US$) of Upper middle income in 2002 to that in 2004?
Your response must be concise. 0.69. What is the ratio of the Aid flow (current US$) in Papua New Guinea in 2002 to that in 2004?
Make the answer very short. 0.71. What is the ratio of the Aid flow (current US$) in Uzbekistan in 2002 to that in 2004?
Offer a very short reply. 0.15. What is the ratio of the Aid flow (current US$) in Upper middle income in 2002 to that in 2005?
Your answer should be compact. 0.48. What is the ratio of the Aid flow (current US$) in Brazil in 2002 to that in 2005?
Offer a terse response. 0.62. What is the ratio of the Aid flow (current US$) of Papua New Guinea in 2002 to that in 2005?
Ensure brevity in your answer.  0.62. What is the ratio of the Aid flow (current US$) in Upper middle income in 2002 to that in 2006?
Give a very brief answer. 0.58. What is the ratio of the Aid flow (current US$) in Brazil in 2002 to that in 2006?
Ensure brevity in your answer.  0.75. What is the ratio of the Aid flow (current US$) of Papua New Guinea in 2002 to that in 2006?
Keep it short and to the point. 0.44. What is the ratio of the Aid flow (current US$) in Uzbekistan in 2002 to that in 2006?
Offer a terse response. 0.67. What is the ratio of the Aid flow (current US$) in Upper middle income in 2003 to that in 2004?
Make the answer very short. 1.18. What is the ratio of the Aid flow (current US$) of Papua New Guinea in 2003 to that in 2004?
Make the answer very short. 0.92. What is the ratio of the Aid flow (current US$) in Uzbekistan in 2003 to that in 2004?
Your answer should be very brief. 0.15. What is the ratio of the Aid flow (current US$) in Upper middle income in 2003 to that in 2005?
Keep it short and to the point. 0.82. What is the ratio of the Aid flow (current US$) in Brazil in 2003 to that in 2005?
Provide a short and direct response. 0.69. What is the ratio of the Aid flow (current US$) of Papua New Guinea in 2003 to that in 2005?
Keep it short and to the point. 0.81. What is the ratio of the Aid flow (current US$) of Upper middle income in 2003 to that in 2006?
Offer a terse response. 0.99. What is the ratio of the Aid flow (current US$) of Papua New Guinea in 2003 to that in 2006?
Ensure brevity in your answer.  0.56. What is the ratio of the Aid flow (current US$) of Upper middle income in 2004 to that in 2005?
Provide a short and direct response. 0.69. What is the ratio of the Aid flow (current US$) in Brazil in 2004 to that in 2005?
Provide a short and direct response. 0.83. What is the ratio of the Aid flow (current US$) of Papua New Guinea in 2004 to that in 2005?
Make the answer very short. 0.88. What is the ratio of the Aid flow (current US$) of Uzbekistan in 2004 to that in 2005?
Provide a succinct answer. 0.81. What is the ratio of the Aid flow (current US$) in Upper middle income in 2004 to that in 2006?
Offer a terse response. 0.84. What is the ratio of the Aid flow (current US$) of Brazil in 2004 to that in 2006?
Your answer should be compact. 1. What is the ratio of the Aid flow (current US$) of Papua New Guinea in 2004 to that in 2006?
Your answer should be very brief. 0.61. What is the ratio of the Aid flow (current US$) of Uzbekistan in 2004 to that in 2006?
Your answer should be compact. 4.33. What is the ratio of the Aid flow (current US$) in Upper middle income in 2005 to that in 2006?
Your response must be concise. 1.21. What is the ratio of the Aid flow (current US$) in Brazil in 2005 to that in 2006?
Your answer should be very brief. 1.21. What is the ratio of the Aid flow (current US$) in Papua New Guinea in 2005 to that in 2006?
Give a very brief answer. 0.7. What is the ratio of the Aid flow (current US$) in Uzbekistan in 2005 to that in 2006?
Provide a short and direct response. 5.33. What is the difference between the highest and the second highest Aid flow (current US$) in Upper middle income?
Keep it short and to the point. 7.28e+06. What is the difference between the highest and the second highest Aid flow (current US$) in Brazil?
Provide a succinct answer. 5.00e+04. What is the difference between the highest and the second highest Aid flow (current US$) of Papua New Guinea?
Your answer should be compact. 4.12e+06. What is the difference between the highest and the lowest Aid flow (current US$) of Upper middle income?
Offer a very short reply. 2.68e+07. What is the difference between the highest and the lowest Aid flow (current US$) in Brazil?
Keep it short and to the point. 1.10e+05. What is the difference between the highest and the lowest Aid flow (current US$) in Papua New Guinea?
Provide a succinct answer. 7.71e+06. What is the difference between the highest and the lowest Aid flow (current US$) of Uzbekistan?
Your answer should be compact. 1.40e+05. 